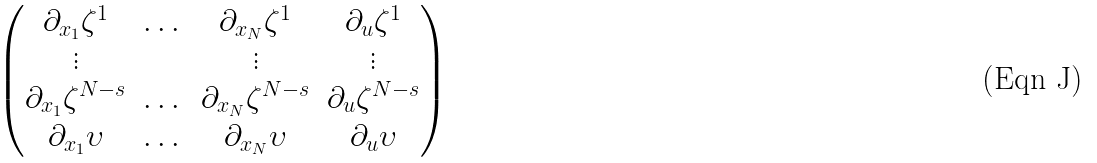<formula> <loc_0><loc_0><loc_500><loc_500>\begin{pmatrix} \partial _ { x _ { 1 } } \zeta ^ { 1 } & \dots & \partial _ { x _ { N } } \zeta ^ { 1 } & \partial _ { u } \zeta ^ { 1 } \\ \vdots & & \vdots & \vdots \\ \partial _ { x _ { 1 } } \zeta ^ { N - s } & \dots & \partial _ { x _ { N } } \zeta ^ { N - s } & \partial _ { u } \zeta ^ { N - s } \\ \partial _ { x _ { 1 } } \upsilon & \dots & \partial _ { x _ { N } } \upsilon & \partial _ { u } \upsilon \end{pmatrix}</formula> 